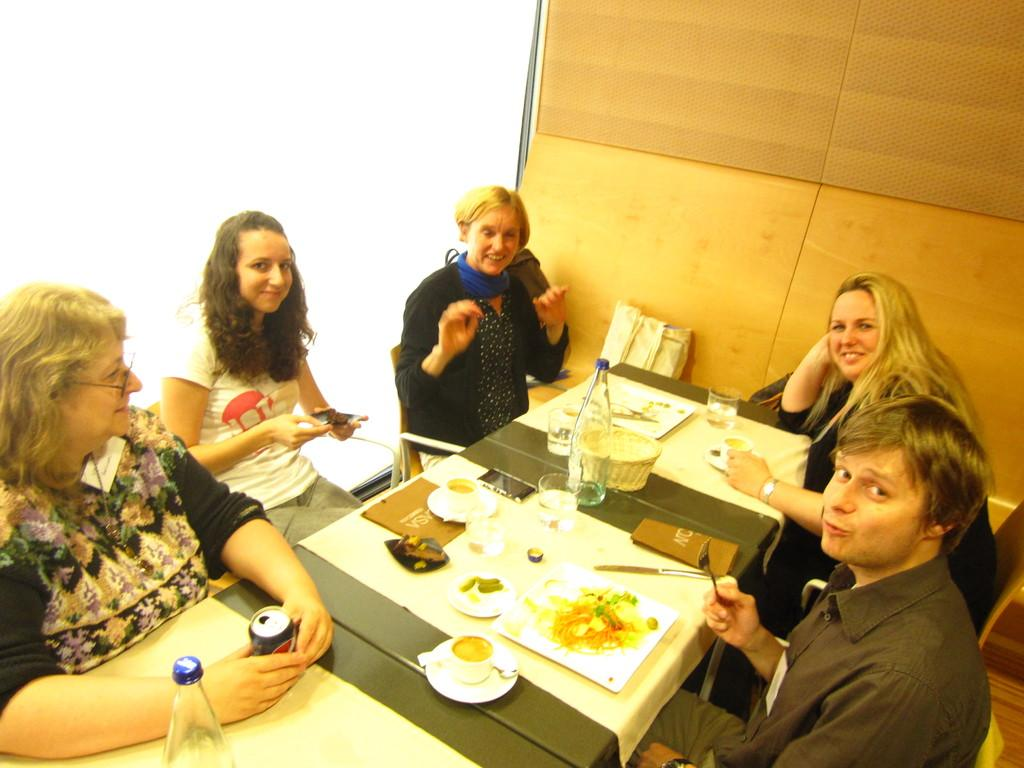How many people are in the image? There is a group of persons in the image. What are the persons doing in the image? The persons are sitting on a chair. What type of food can be seen in the image? There is food on a plate in the image. What is on the table in the image? There is a bottle on a table in the image. How many women are in the image? There is no mention of women in the image. The image only mentions a group of persons. 